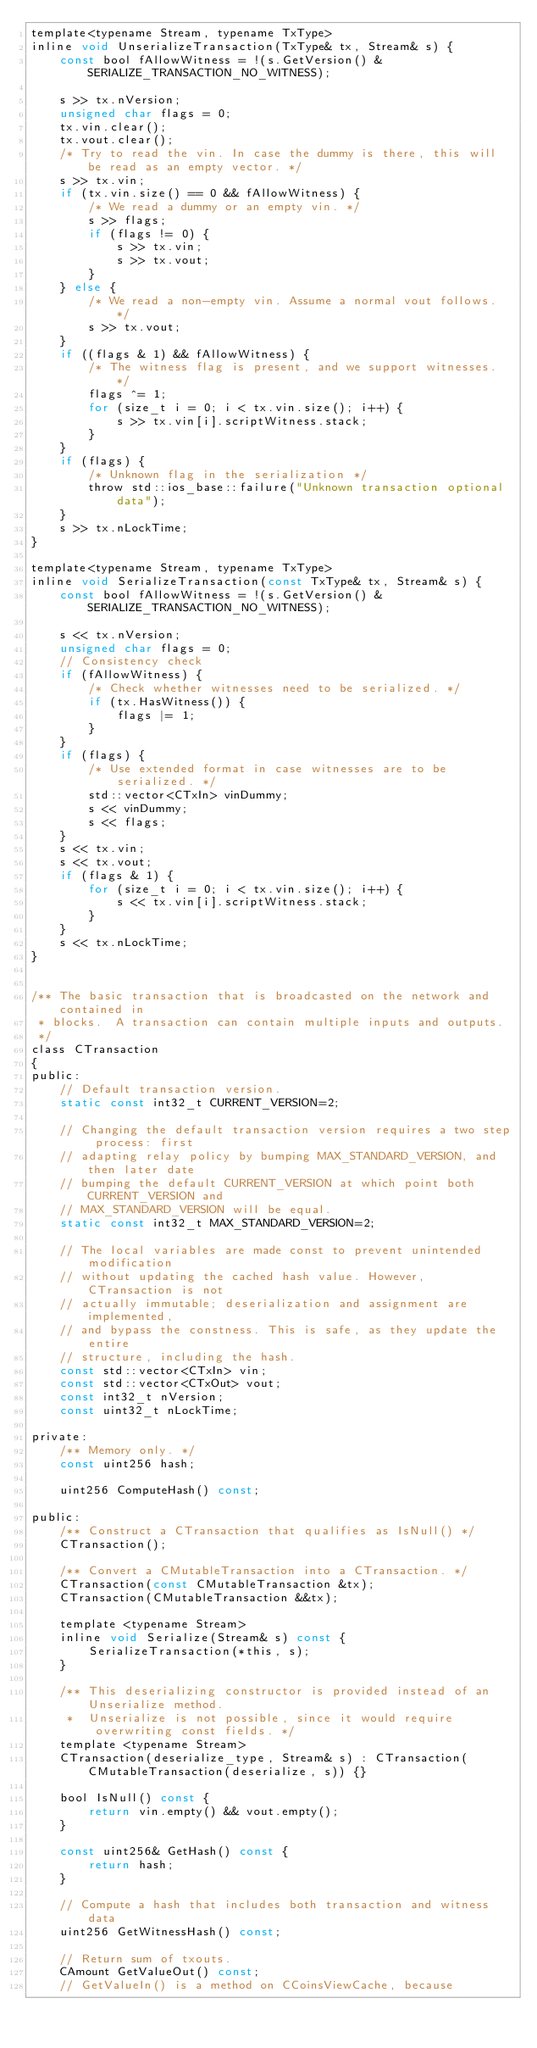<code> <loc_0><loc_0><loc_500><loc_500><_C_>template<typename Stream, typename TxType>
inline void UnserializeTransaction(TxType& tx, Stream& s) {
    const bool fAllowWitness = !(s.GetVersion() & SERIALIZE_TRANSACTION_NO_WITNESS);

    s >> tx.nVersion;
    unsigned char flags = 0;
    tx.vin.clear();
    tx.vout.clear();
    /* Try to read the vin. In case the dummy is there, this will be read as an empty vector. */
    s >> tx.vin;
    if (tx.vin.size() == 0 && fAllowWitness) {
        /* We read a dummy or an empty vin. */
        s >> flags;
        if (flags != 0) {
            s >> tx.vin;
            s >> tx.vout;
        }
    } else {
        /* We read a non-empty vin. Assume a normal vout follows. */
        s >> tx.vout;
    }
    if ((flags & 1) && fAllowWitness) {
        /* The witness flag is present, and we support witnesses. */
        flags ^= 1;
        for (size_t i = 0; i < tx.vin.size(); i++) {
            s >> tx.vin[i].scriptWitness.stack;
        }
    }
    if (flags) {
        /* Unknown flag in the serialization */
        throw std::ios_base::failure("Unknown transaction optional data");
    }
    s >> tx.nLockTime;
}

template<typename Stream, typename TxType>
inline void SerializeTransaction(const TxType& tx, Stream& s) {
    const bool fAllowWitness = !(s.GetVersion() & SERIALIZE_TRANSACTION_NO_WITNESS);

    s << tx.nVersion;
    unsigned char flags = 0;
    // Consistency check
    if (fAllowWitness) {
        /* Check whether witnesses need to be serialized. */
        if (tx.HasWitness()) {
            flags |= 1;
        }
    }
    if (flags) {
        /* Use extended format in case witnesses are to be serialized. */
        std::vector<CTxIn> vinDummy;
        s << vinDummy;
        s << flags;
    }
    s << tx.vin;
    s << tx.vout;
    if (flags & 1) {
        for (size_t i = 0; i < tx.vin.size(); i++) {
            s << tx.vin[i].scriptWitness.stack;
        }
    }
    s << tx.nLockTime;
}


/** The basic transaction that is broadcasted on the network and contained in
 * blocks.  A transaction can contain multiple inputs and outputs.
 */
class CTransaction
{
public:
    // Default transaction version.
    static const int32_t CURRENT_VERSION=2;

    // Changing the default transaction version requires a two step process: first
    // adapting relay policy by bumping MAX_STANDARD_VERSION, and then later date
    // bumping the default CURRENT_VERSION at which point both CURRENT_VERSION and
    // MAX_STANDARD_VERSION will be equal.
    static const int32_t MAX_STANDARD_VERSION=2;

    // The local variables are made const to prevent unintended modification
    // without updating the cached hash value. However, CTransaction is not
    // actually immutable; deserialization and assignment are implemented,
    // and bypass the constness. This is safe, as they update the entire
    // structure, including the hash.
    const std::vector<CTxIn> vin;
    const std::vector<CTxOut> vout;
    const int32_t nVersion;
    const uint32_t nLockTime;

private:
    /** Memory only. */
    const uint256 hash;

    uint256 ComputeHash() const;

public:
    /** Construct a CTransaction that qualifies as IsNull() */
    CTransaction();

    /** Convert a CMutableTransaction into a CTransaction. */
    CTransaction(const CMutableTransaction &tx);
    CTransaction(CMutableTransaction &&tx);

    template <typename Stream>
    inline void Serialize(Stream& s) const {
        SerializeTransaction(*this, s);
    }

    /** This deserializing constructor is provided instead of an Unserialize method.
     *  Unserialize is not possible, since it would require overwriting const fields. */
    template <typename Stream>
    CTransaction(deserialize_type, Stream& s) : CTransaction(CMutableTransaction(deserialize, s)) {}

    bool IsNull() const {
        return vin.empty() && vout.empty();
    }

    const uint256& GetHash() const {
        return hash;
    }

    // Compute a hash that includes both transaction and witness data
    uint256 GetWitnessHash() const;

    // Return sum of txouts.
    CAmount GetValueOut() const;
    // GetValueIn() is a method on CCoinsViewCache, because</code> 